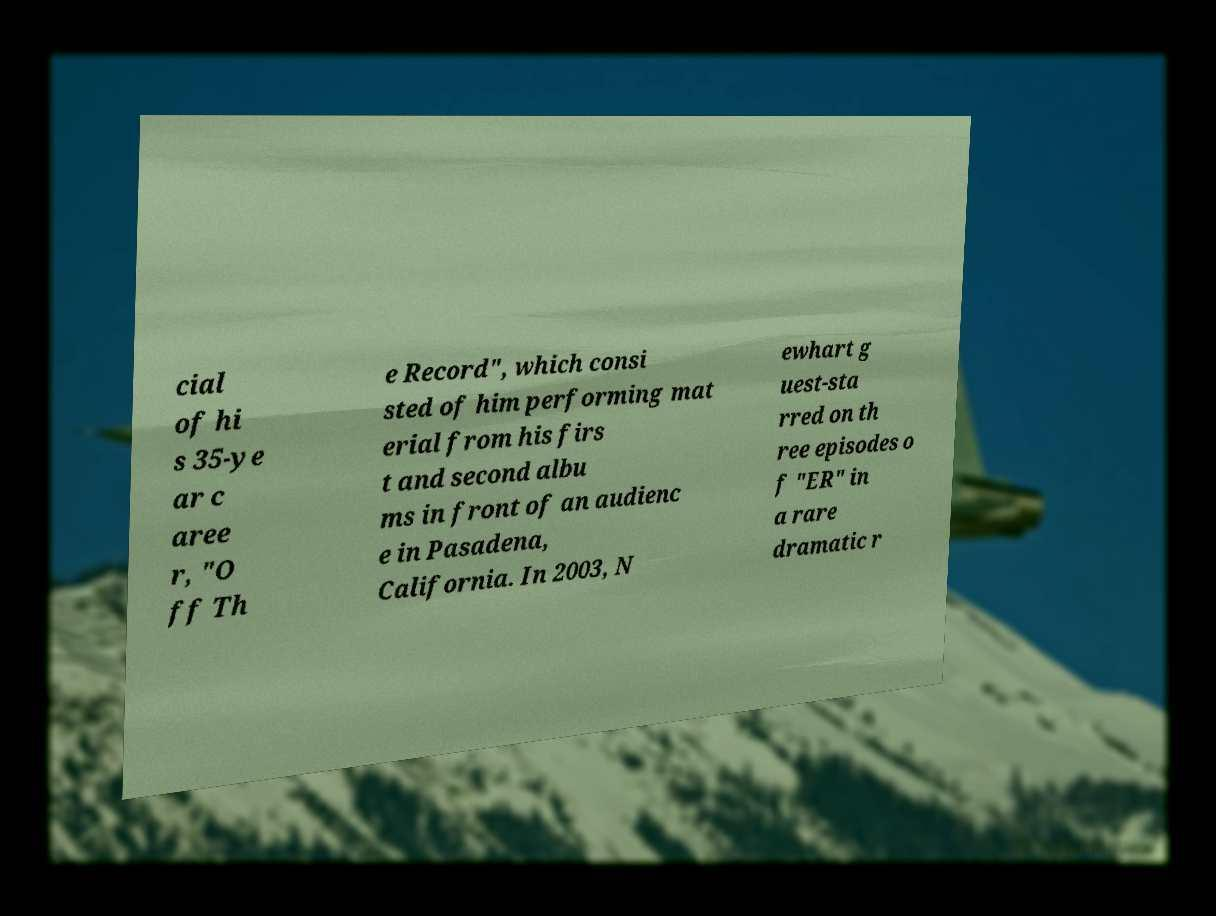What messages or text are displayed in this image? I need them in a readable, typed format. cial of hi s 35-ye ar c aree r, "O ff Th e Record", which consi sted of him performing mat erial from his firs t and second albu ms in front of an audienc e in Pasadena, California. In 2003, N ewhart g uest-sta rred on th ree episodes o f "ER" in a rare dramatic r 